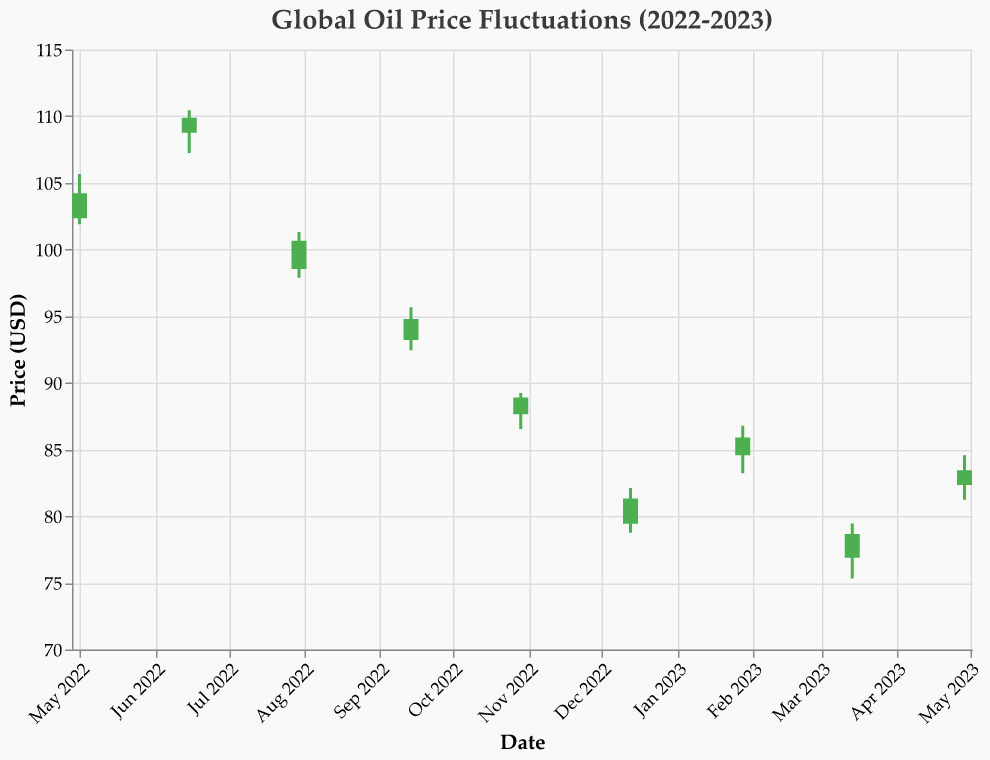What is the highest price of oil shown in the data? To find the highest price of oil, look at the "High" prices across all data points. The highest price is 110.45, which occurred on June 15, 2022.
Answer: 110.45 What is the title of the figure? The title is located at the top of the chart. The title reads "Global Oil Price Fluctuations (2022-2023)."
Answer: Global Oil Price Fluctuations (2022-2023) Which month had the lowest opening price? To determine the month with the lowest opening price, scan through the "Open" column. The lowest opening price is 76.89, which occurred in March 2023.
Answer: March 2023 What is the difference between the highest and lowest prices in July 2022? For July 2022, the high is 101.32 and the low is 97.89. The difference is 101.32 - 97.89 = 3.43.
Answer: 3.43 Which data point shows a price increase from opening to closing? Scan the dates and compare the "Open" and "Close" prices. Look for dates where "Close" is higher than "Open". For example, on June 15, 2022, the opening price is 108.76, and the closing price is 109.88, indicating an increase.
Answer: June 15, 2022 Did the oil price increase between December 13, 2022 and January 28, 2023? Compare the closing price on December 13, 2022 (81.32) with the closing price on January 28, 2023 (85.90). Since 85.90 > 81.32, the price increased.
Answer: Yes Calculate the average closing price over the given time period. To find the average closing price, sum up all the closing prices and then divide by the number of data points. Sum of closing prices: 104.22 + 109.88 + 100.65 + 94.78 + 88.90 + 81.32 + 85.90 + 78.67 + 83.45 = 828.77. Number of data points: 9. Average = 828.77 / 9 = 92.08667.
Answer: 92.09 Considering the entire data set, did the oil prices show an overall upward or downward trend? To determine the trend, compare the earliest available closing price (104.22 on May 1, 2022) with the latest closing price (83.45 on April 29, 2023). Since 83.45 < 104.22, it shows a downward trend.
Answer: Downward What are the high and low prices for the month of April 2023? For April 2023 (dated April 29, 2023), the high price is 84.56 and the low price is 81.23.
Answer: High: 84.56, Low: 81.23 Between which two consecutive months was the highest volatility observed in terms of high and low price differences? Calculate the difference between high and low prices for each month and compare them. The difference for May 2022: 105.67 - 101.89 = 3.78; for June 2022: 110.45 - 107.23 = 3.22; and so on. The highest difference between consecutive months happens to be between May 2022 and June 2022 with differences 3.78 and 3.22 respectively.
Answer: May 2022 to June 2022 